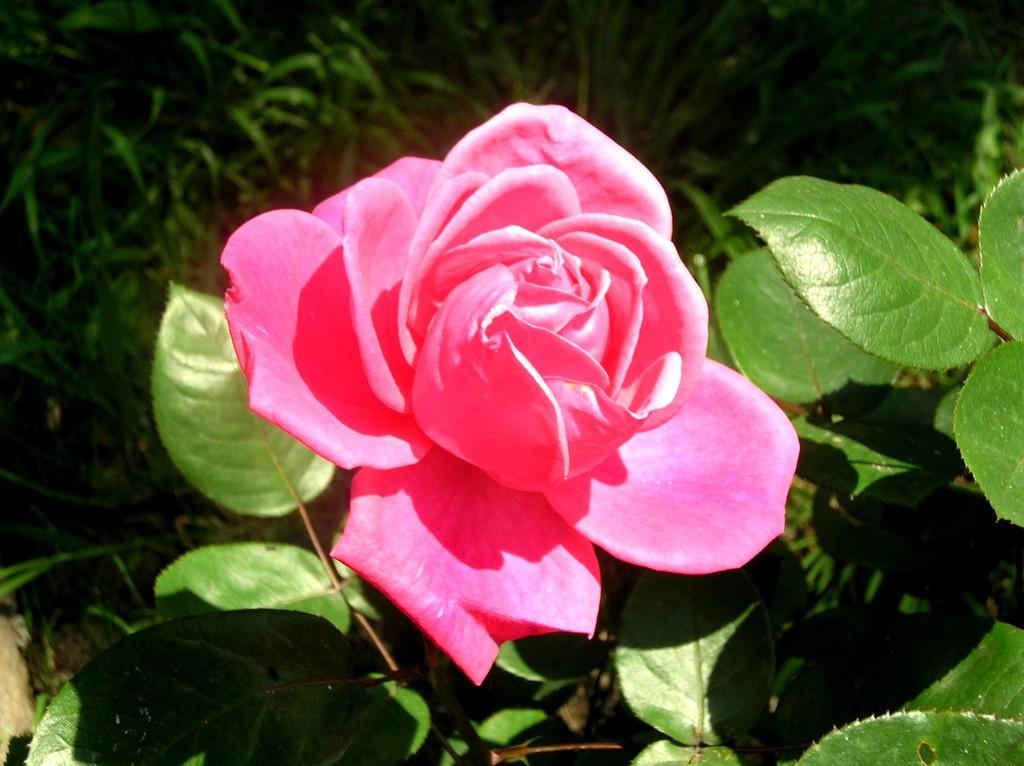Describe this image in one or two sentences. In this image we can see a rose, and some plants, and the background is blurred. 